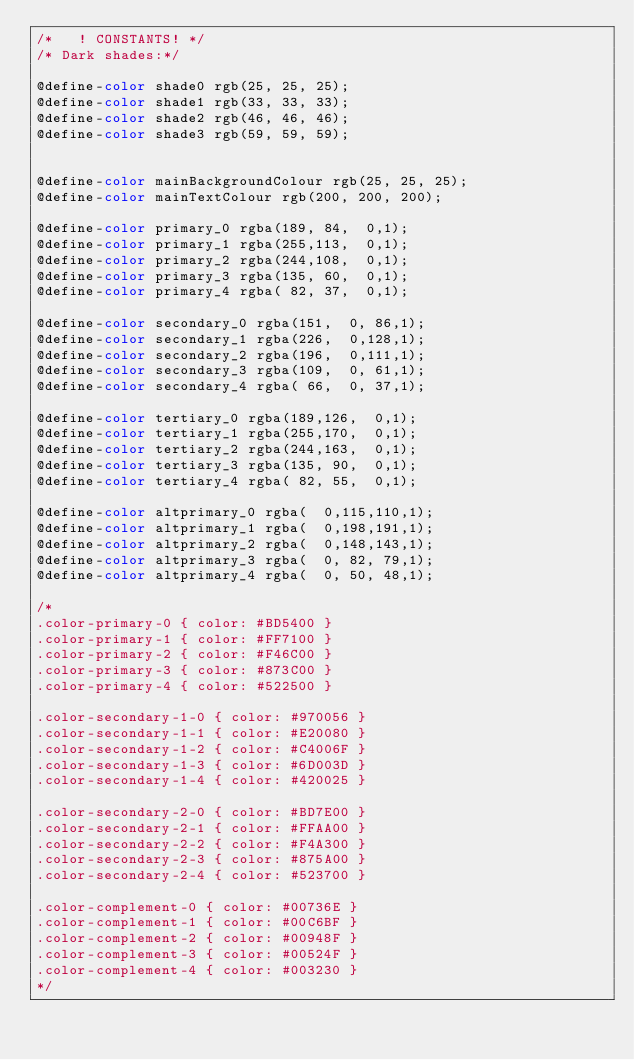Convert code to text. <code><loc_0><loc_0><loc_500><loc_500><_CSS_>/*	 ! CONSTANTS!	*/
/* Dark shades:*/

@define-color shade0 rgb(25, 25, 25);
@define-color shade1 rgb(33, 33, 33);
@define-color shade2 rgb(46, 46, 46);
@define-color shade3 rgb(59, 59, 59);


@define-color mainBackgroundColour rgb(25, 25, 25);
@define-color mainTextColour rgb(200, 200, 200);

@define-color primary_0 rgba(189, 84,  0,1);
@define-color primary_1 rgba(255,113,  0,1);
@define-color primary_2 rgba(244,108,  0,1);
@define-color primary_3 rgba(135, 60,  0,1);
@define-color primary_4 rgba( 82, 37,  0,1);

@define-color secondary_0 rgba(151,  0, 86,1);
@define-color secondary_1 rgba(226,  0,128,1);
@define-color secondary_2 rgba(196,  0,111,1);
@define-color secondary_3 rgba(109,  0, 61,1);
@define-color secondary_4 rgba( 66,  0, 37,1);

@define-color tertiary_0 rgba(189,126,  0,1);
@define-color tertiary_1 rgba(255,170,  0,1);
@define-color tertiary_2 rgba(244,163,  0,1);
@define-color tertiary_3 rgba(135, 90,  0,1);
@define-color tertiary_4 rgba( 82, 55,  0,1);

@define-color altprimary_0 rgba(  0,115,110,1);
@define-color altprimary_1 rgba(  0,198,191,1);
@define-color altprimary_2 rgba(  0,148,143,1);
@define-color altprimary_3 rgba(  0, 82, 79,1);
@define-color altprimary_4 rgba(  0, 50, 48,1);

/*
.color-primary-0 { color: #BD5400 }	
.color-primary-1 { color: #FF7100 }
.color-primary-2 { color: #F46C00 }
.color-primary-3 { color: #873C00 }
.color-primary-4 { color: #522500 }

.color-secondary-1-0 { color: #970056 }	
.color-secondary-1-1 { color: #E20080 }
.color-secondary-1-2 { color: #C4006F }
.color-secondary-1-3 { color: #6D003D }
.color-secondary-1-4 { color: #420025 }

.color-secondary-2-0 { color: #BD7E00 }	
.color-secondary-2-1 { color: #FFAA00 }
.color-secondary-2-2 { color: #F4A300 }
.color-secondary-2-3 { color: #875A00 }
.color-secondary-2-4 { color: #523700 }

.color-complement-0 { color: #00736E }	
.color-complement-1 { color: #00C6BF }
.color-complement-2 { color: #00948F }
.color-complement-3 { color: #00524F }
.color-complement-4 { color: #003230 }
*/

</code> 